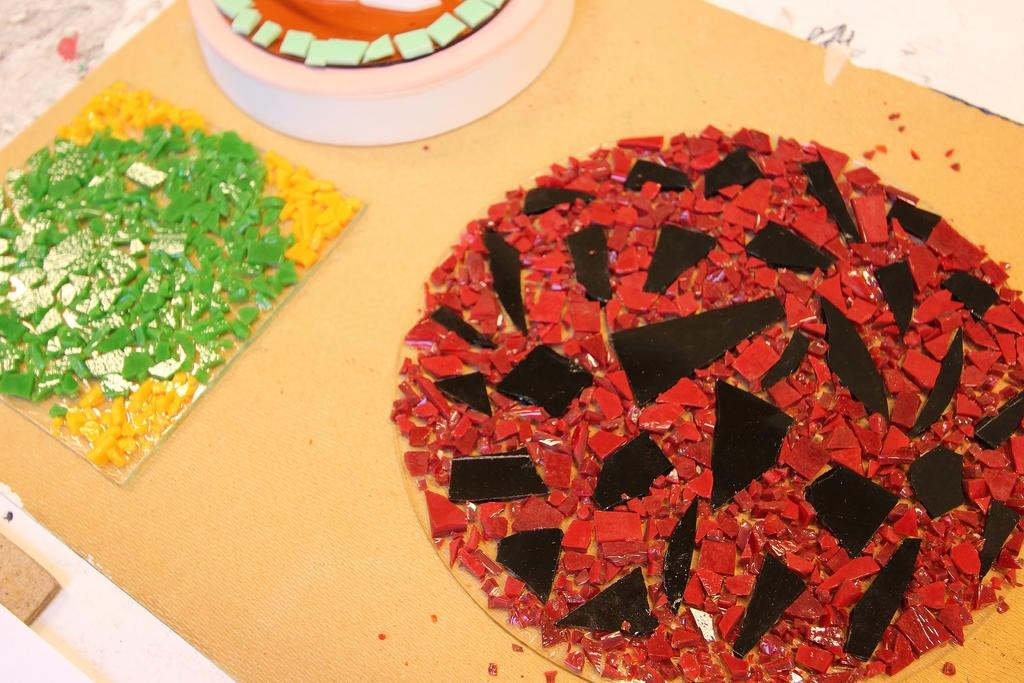What type of food can be seen in the image? There are chocolate pieces and cake in the image. What else is present on the table in the image? There are other eatable items on a table in the image. How many bombs can be seen in the image? There are no bombs present in the image; it features chocolate pieces, cake, and other eatable items on a table. What color are the eyes of the person in the image? There is no person present in the image, so their eye color cannot be determined. 